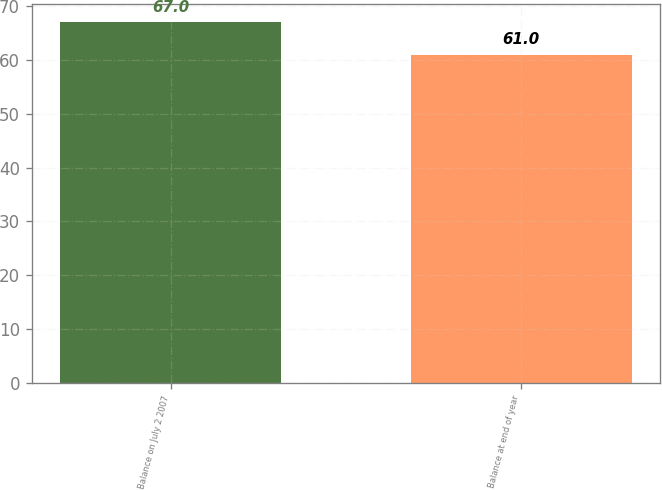<chart> <loc_0><loc_0><loc_500><loc_500><bar_chart><fcel>Balance on July 2 2007<fcel>Balance at end of year<nl><fcel>67<fcel>61<nl></chart> 